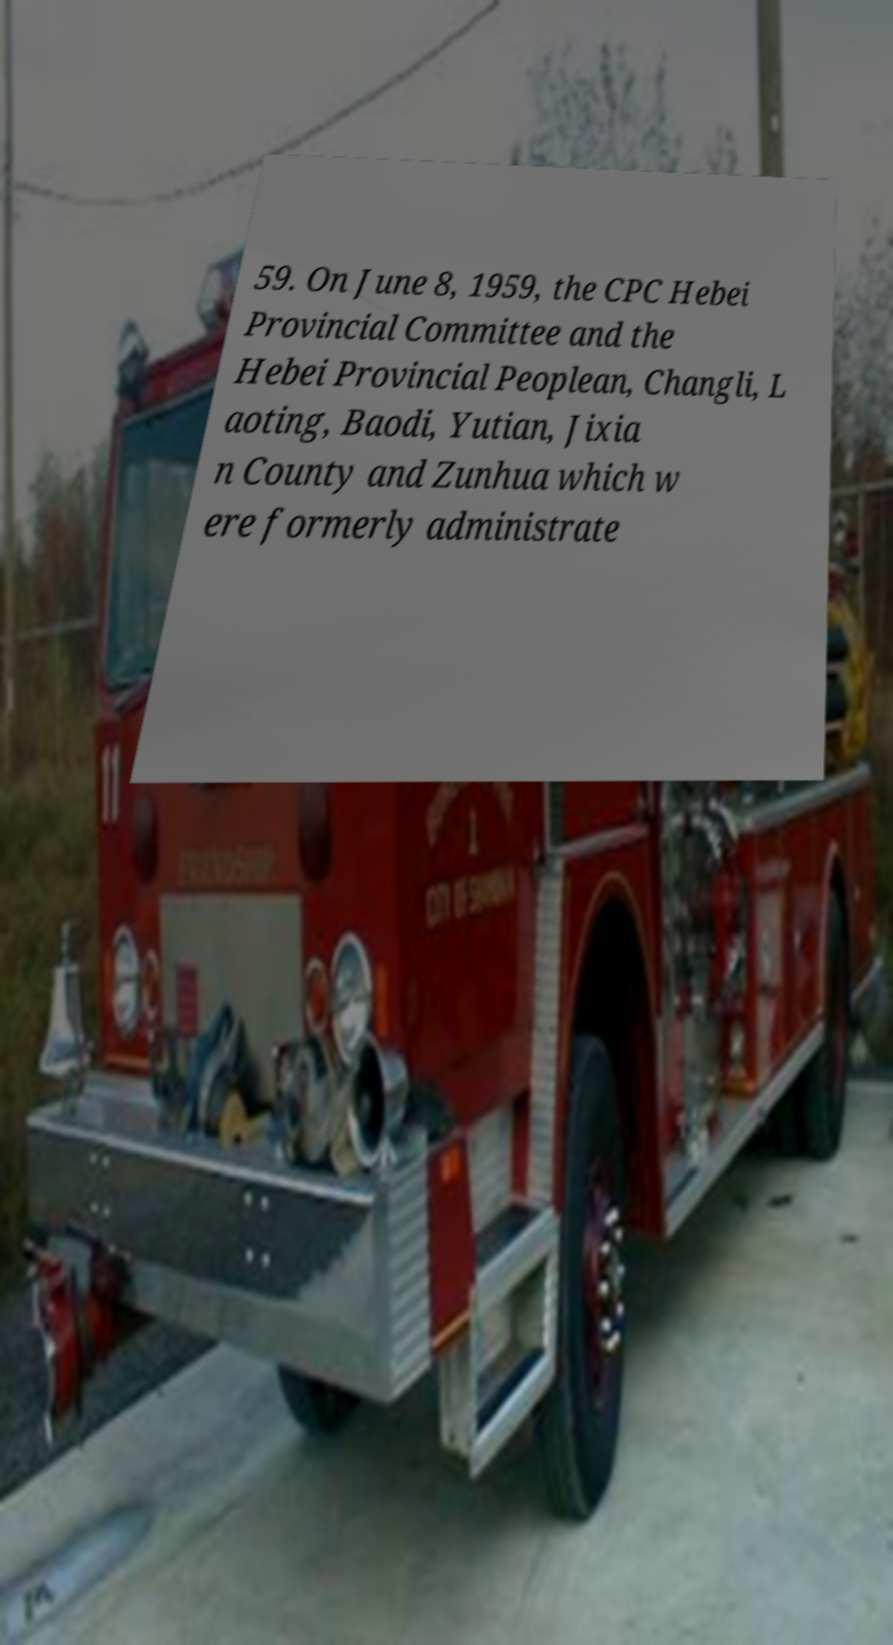Please identify and transcribe the text found in this image. 59. On June 8, 1959, the CPC Hebei Provincial Committee and the Hebei Provincial Peoplean, Changli, L aoting, Baodi, Yutian, Jixia n County and Zunhua which w ere formerly administrate 